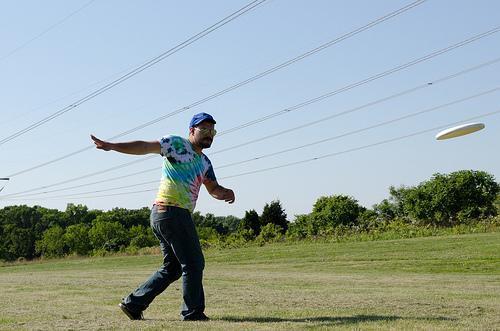How many frisbees are there?
Give a very brief answer. 1. 